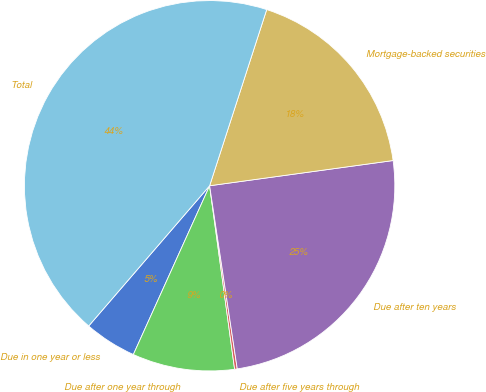Convert chart. <chart><loc_0><loc_0><loc_500><loc_500><pie_chart><fcel>Due in one year or less<fcel>Due after one year through<fcel>Due after five years through<fcel>Due after ten years<fcel>Mortgage-backed securities<fcel>Total<nl><fcel>4.57%<fcel>8.91%<fcel>0.23%<fcel>24.79%<fcel>17.84%<fcel>43.66%<nl></chart> 